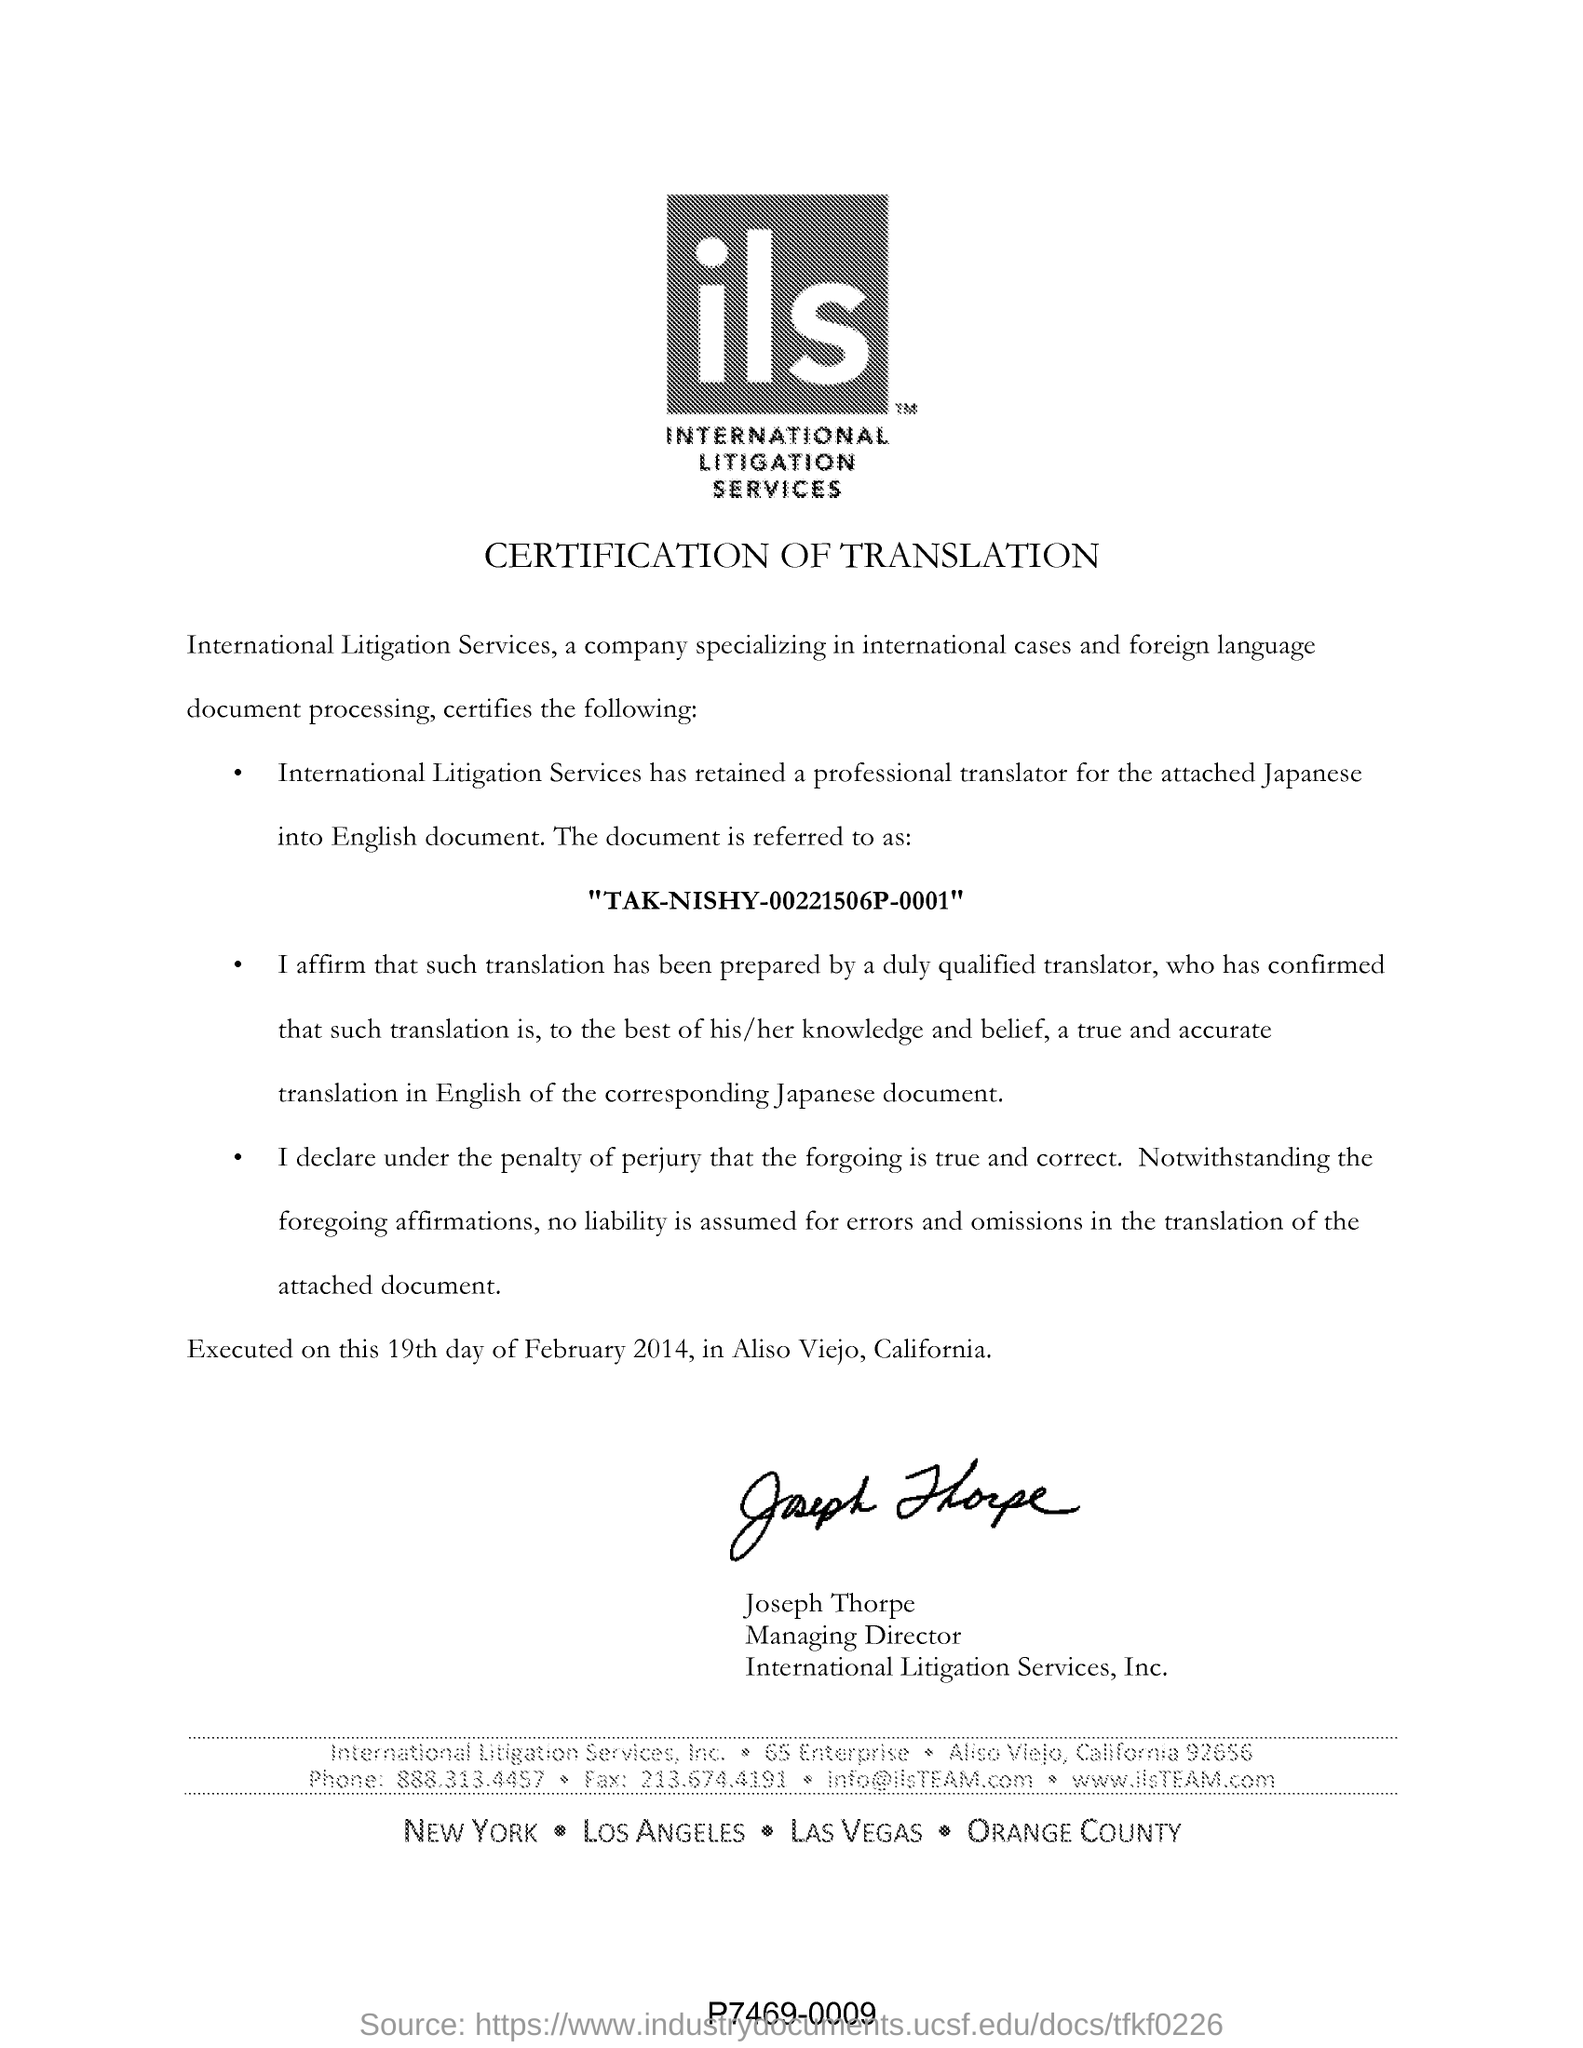Who retained a professional translator
Make the answer very short. International Litigation Services. Who is the managing director of international litigation services,inc.
Offer a terse response. Joseph Thorpe. What is the fullform of ILS?
Your response must be concise. INTERNATIONAL LITIGATION SERVICES. 